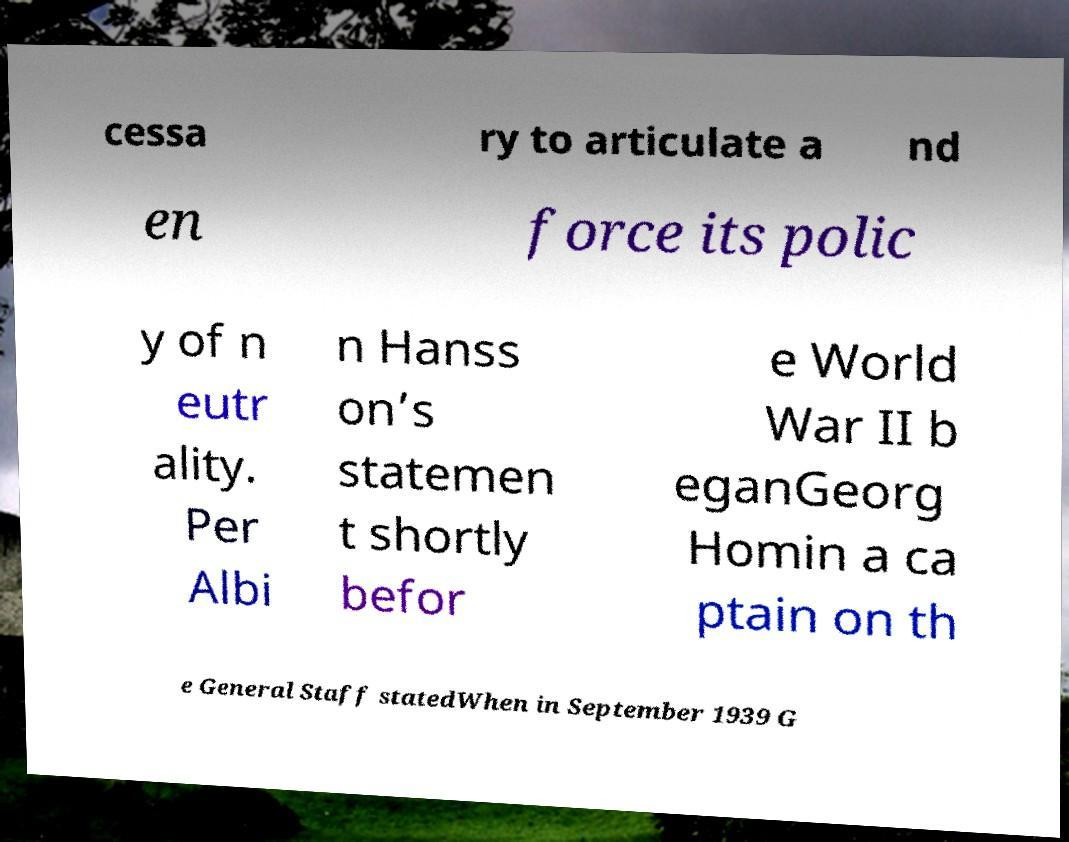What messages or text are displayed in this image? I need them in a readable, typed format. cessa ry to articulate a nd en force its polic y of n eutr ality. Per Albi n Hanss on’s statemen t shortly befor e World War II b eganGeorg Homin a ca ptain on th e General Staff statedWhen in September 1939 G 